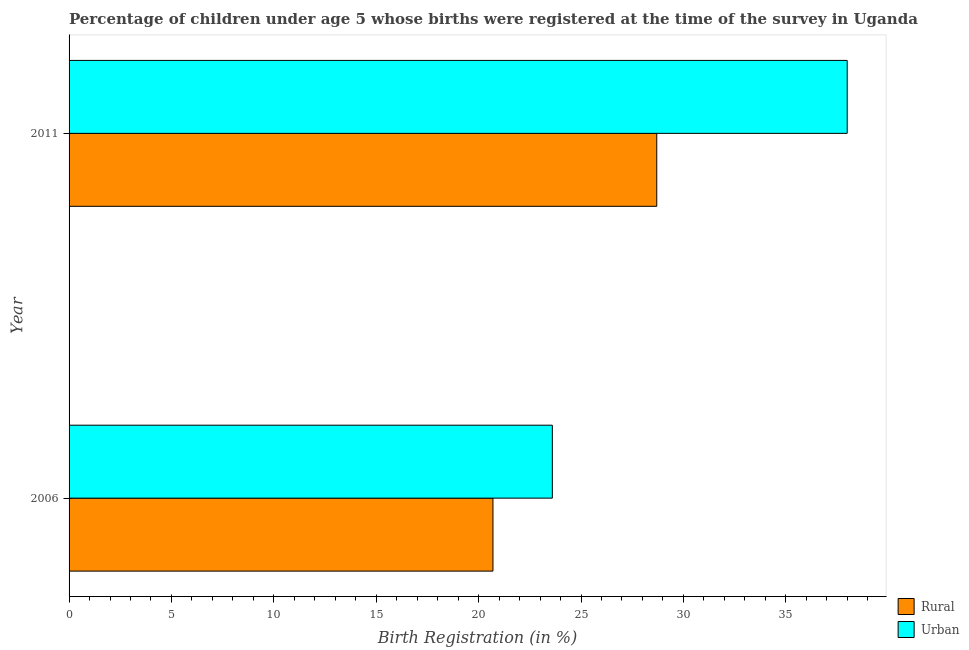How many different coloured bars are there?
Your answer should be compact. 2. How many groups of bars are there?
Keep it short and to the point. 2. How many bars are there on the 2nd tick from the top?
Make the answer very short. 2. In how many cases, is the number of bars for a given year not equal to the number of legend labels?
Offer a very short reply. 0. What is the rural birth registration in 2011?
Keep it short and to the point. 28.7. Across all years, what is the maximum urban birth registration?
Ensure brevity in your answer.  38. Across all years, what is the minimum rural birth registration?
Make the answer very short. 20.7. In which year was the rural birth registration minimum?
Your response must be concise. 2006. What is the total rural birth registration in the graph?
Give a very brief answer. 49.4. What is the difference between the urban birth registration in 2006 and that in 2011?
Your response must be concise. -14.4. What is the difference between the urban birth registration in 2006 and the rural birth registration in 2011?
Your response must be concise. -5.1. What is the average rural birth registration per year?
Make the answer very short. 24.7. What is the ratio of the urban birth registration in 2006 to that in 2011?
Ensure brevity in your answer.  0.62. What does the 1st bar from the top in 2006 represents?
Ensure brevity in your answer.  Urban. What does the 2nd bar from the bottom in 2006 represents?
Make the answer very short. Urban. Are all the bars in the graph horizontal?
Provide a succinct answer. Yes. What is the difference between two consecutive major ticks on the X-axis?
Give a very brief answer. 5. Does the graph contain any zero values?
Keep it short and to the point. No. Does the graph contain grids?
Provide a succinct answer. No. Where does the legend appear in the graph?
Offer a very short reply. Bottom right. How many legend labels are there?
Your answer should be very brief. 2. How are the legend labels stacked?
Provide a short and direct response. Vertical. What is the title of the graph?
Offer a terse response. Percentage of children under age 5 whose births were registered at the time of the survey in Uganda. Does "Frequency of shipment arrival" appear as one of the legend labels in the graph?
Your response must be concise. No. What is the label or title of the X-axis?
Ensure brevity in your answer.  Birth Registration (in %). What is the label or title of the Y-axis?
Provide a short and direct response. Year. What is the Birth Registration (in %) of Rural in 2006?
Offer a very short reply. 20.7. What is the Birth Registration (in %) of Urban in 2006?
Ensure brevity in your answer.  23.6. What is the Birth Registration (in %) in Rural in 2011?
Your response must be concise. 28.7. What is the Birth Registration (in %) of Urban in 2011?
Your answer should be very brief. 38. Across all years, what is the maximum Birth Registration (in %) in Rural?
Your answer should be compact. 28.7. Across all years, what is the maximum Birth Registration (in %) in Urban?
Provide a short and direct response. 38. Across all years, what is the minimum Birth Registration (in %) of Rural?
Provide a short and direct response. 20.7. Across all years, what is the minimum Birth Registration (in %) of Urban?
Give a very brief answer. 23.6. What is the total Birth Registration (in %) of Rural in the graph?
Provide a short and direct response. 49.4. What is the total Birth Registration (in %) in Urban in the graph?
Ensure brevity in your answer.  61.6. What is the difference between the Birth Registration (in %) of Rural in 2006 and that in 2011?
Keep it short and to the point. -8. What is the difference between the Birth Registration (in %) in Urban in 2006 and that in 2011?
Give a very brief answer. -14.4. What is the difference between the Birth Registration (in %) in Rural in 2006 and the Birth Registration (in %) in Urban in 2011?
Ensure brevity in your answer.  -17.3. What is the average Birth Registration (in %) in Rural per year?
Your answer should be compact. 24.7. What is the average Birth Registration (in %) of Urban per year?
Give a very brief answer. 30.8. In the year 2011, what is the difference between the Birth Registration (in %) in Rural and Birth Registration (in %) in Urban?
Give a very brief answer. -9.3. What is the ratio of the Birth Registration (in %) of Rural in 2006 to that in 2011?
Your response must be concise. 0.72. What is the ratio of the Birth Registration (in %) in Urban in 2006 to that in 2011?
Keep it short and to the point. 0.62. What is the difference between the highest and the second highest Birth Registration (in %) in Urban?
Ensure brevity in your answer.  14.4. What is the difference between the highest and the lowest Birth Registration (in %) of Rural?
Offer a very short reply. 8. 